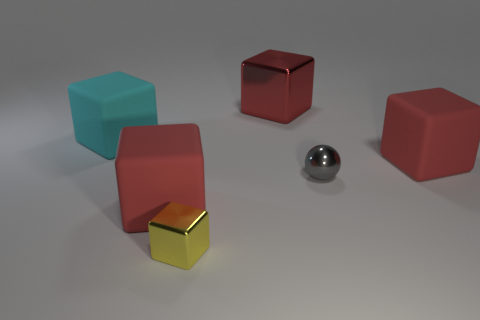How many other objects are the same material as the tiny yellow block?
Offer a terse response. 2. There is a matte thing that is behind the large object on the right side of the gray sphere; what color is it?
Your answer should be compact. Cyan. Is the color of the large matte cube in front of the small gray ball the same as the large metallic object?
Make the answer very short. Yes. Is the size of the gray sphere the same as the yellow thing?
Your answer should be very brief. Yes. There is a red metallic object that is the same size as the cyan cube; what is its shape?
Your response must be concise. Cube. Is the size of the metallic object behind the gray metal object the same as the cyan object?
Provide a succinct answer. Yes. What material is the cyan thing that is the same size as the red metallic object?
Keep it short and to the point. Rubber. There is a red matte object that is in front of the red matte object that is on the right side of the yellow shiny object; are there any big rubber blocks that are behind it?
Make the answer very short. Yes. Are there any other things that are the same shape as the large red shiny thing?
Offer a terse response. Yes. There is a cube that is behind the cyan cube; is it the same color as the tiny thing left of the small gray sphere?
Provide a succinct answer. No. 